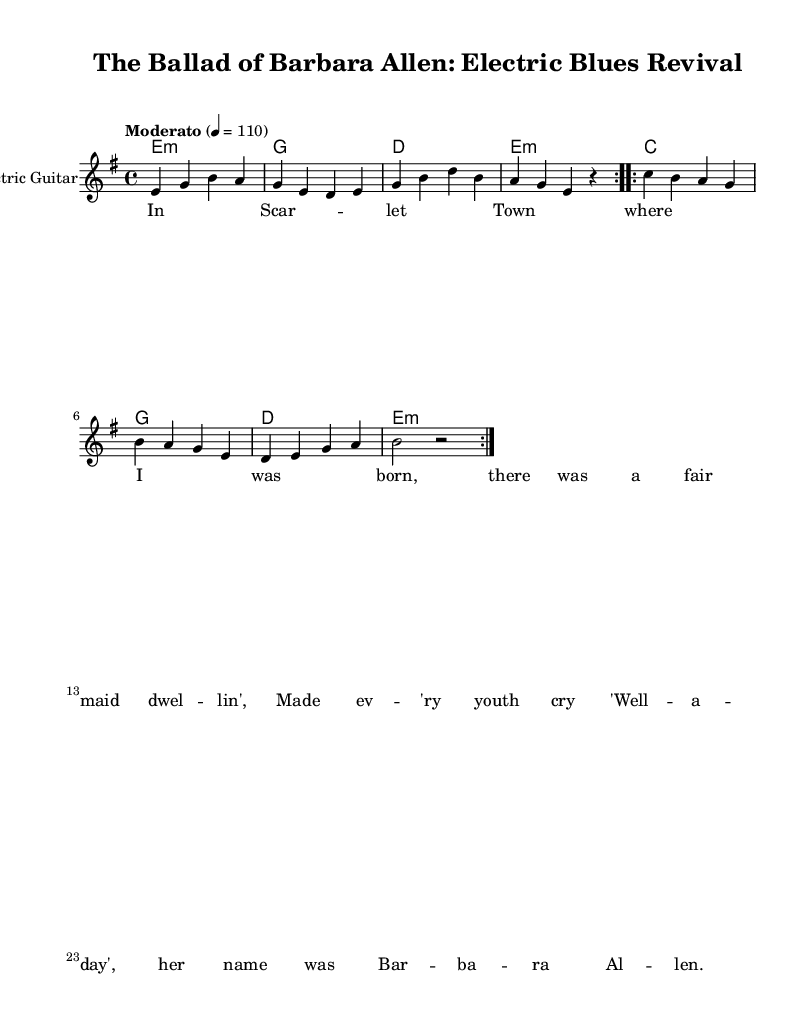What is the key signature of this music? The key signature indicates E minor, signified by one sharp (F#) shown at the beginning of the staff.
Answer: E minor What is the time signature of this piece? The time signature is 4/4, which is indicated after the key signature on the left side of the sheet music.
Answer: 4/4 What is the tempo marking for this piece? The tempo marking states "Moderato" with a metronome marking of 110, suggesting a moderate pace for the performance.
Answer: Moderato How many times is the first section of the electric guitar part repeated? The first section of the electric guitar part is indicated to be repeated two times, as shown by the "repeat volta 2" marking.
Answer: Two What chords are used in the first section of the chord progression? The chords in the first section are E minor, G major, D major, and E minor, as outlined in the chord names underneath the electric guitar part.
Answer: E minor, G, D, E minor What type of musical form does this piece exemplify in electric blues? The piece exemplifies a verse-chorus form, as it transitions between the verses expressed in the lyrics and the repeated sections in the instrumental parts.
Answer: Verse-chorus How does the lyrical content relate to traditional folk themes? The lyrical content recalls traditional folk themes by telling a story about a maiden, which is typical in folk ballads, thereby connecting with the folk origins of the material.
Answer: Storytelling 